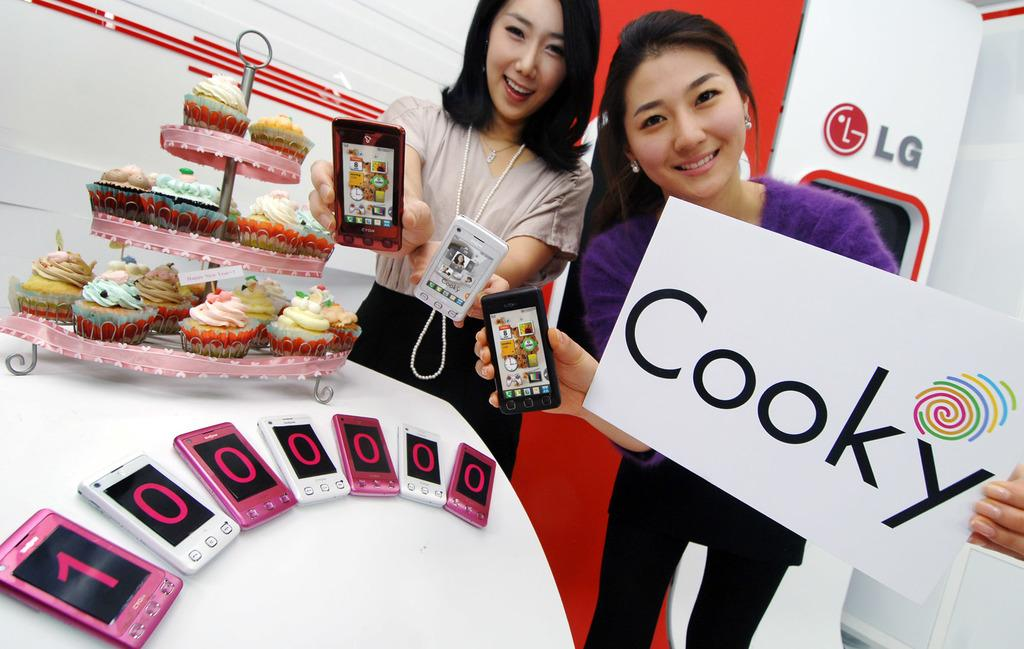How many people are in the image? There are two men in the image. What are the men doing in the image? They are showing a mobile phone named "cooky". What is the price of the mobile phone on sale? The mobile phone is on sale for ten lac pieces. What else can be seen beside the men in the image? There are cookies beside the men. What type of muscle is visible on the men's arms in the image? There is no visible muscle on the men's arms in the image. What color is the dust on the floor in the image? There is no dust visible on the floor in the image. 